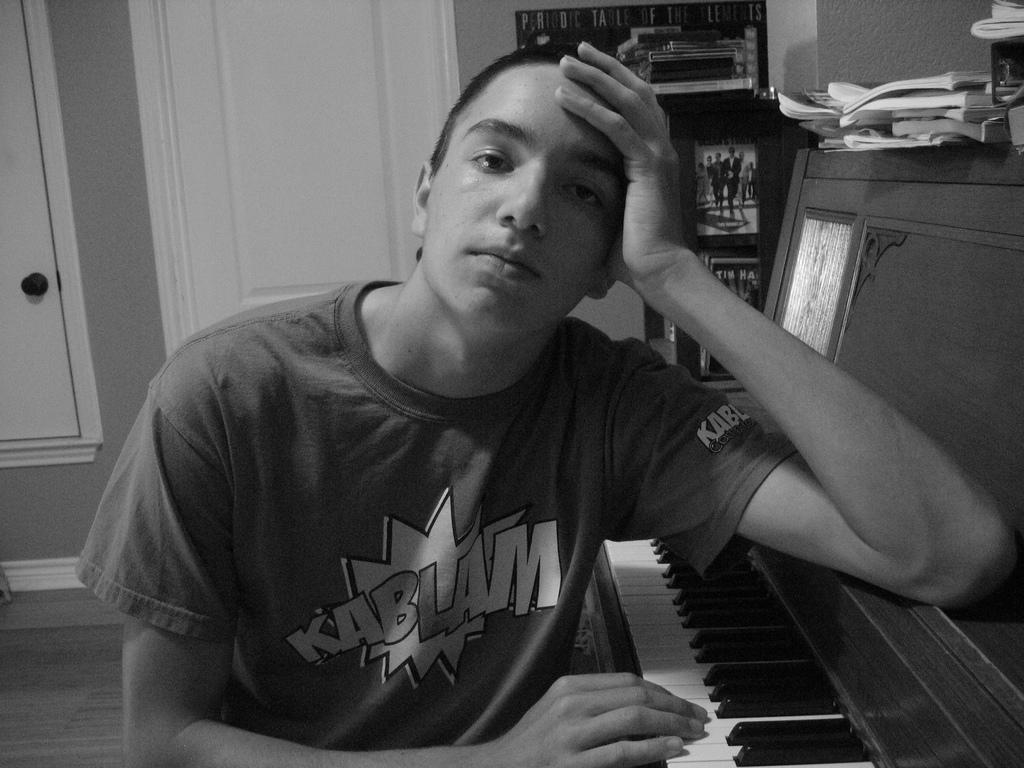Who is the main subject in the image? There is a boy in the image. What is the boy doing in the image? The boy is sitting beside a piano. How is the boy interacting with the camera? The boy is posing to the camera. What type of effect does the canvas have on the dinner in the image? There is no canvas or dinner present in the image, so this question cannot be answered. 